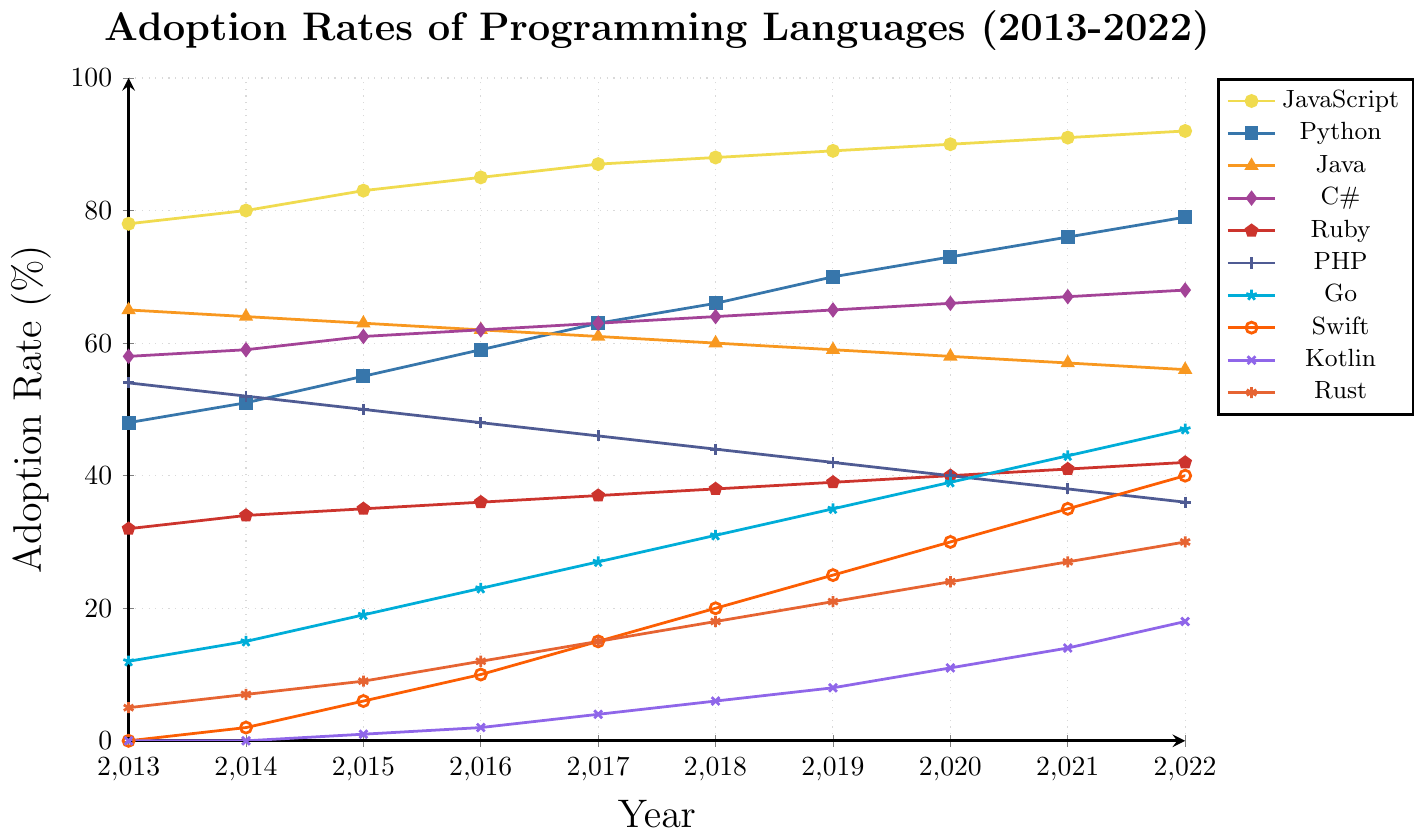Which programming language had the highest adoption rate in 2022? By referring to the legend and the data points for 2022, we can see that JavaScript has the highest adoption rate among all the programming languages listed.
Answer: JavaScript By how much did Python's adoption rate increase from 2013 to 2022? Find Python's adoption rate in 2013 (48%) and in 2022 (79%). The increase is 79 - 48 = 31%.
Answer: 31% Which programming language had the largest drop in adoption rate from 2013 to 2022? Check each language's adoption rate in 2013 and 2022. The language with the decrease is PHP, which dropped from 54% in 2013 to 36% in 2022.
Answer: PHP Between Go and Swift, which language saw a higher adoption rate in 2017? Compare the adoption rates of Go (27%) and Swift (15%) in 2017.
Answer: Go What is the average adoption rate of Java in the given decade? Sum the adoption rates of Java from 2013 to 2022 and divide by the number of years (10). (65 + 64 + 63 + 62 + 61 + 60 + 59 + 58 + 57 + 56) / 10 = 60.5%.
Answer: 60.5% Which language had a higher adoption rate in 2020, Kotlin or Rust? Compare the adoption rates of Kotlin (11%) and Rust (24%) in 2020.
Answer: Rust By how much did Swift’s adoption rate increase from 2013 to 2022? Find Swift's adoption rate in 2013 (0%) and in 2022 (40%). The increase is 40 - 0 = 40%.
Answer: 40% What is the difference in adoption rates between JavaScript and C# in 2019? Find JavaScript's (89%) and C#'s (65%) adoption rates in 2019. The difference is 89 - 65 = 24%.
Answer: 24% Which programming language showed a continuous increase in adoption rate every year from 2013 to 2022? Check each year's adoption rate for each language. Go is the language that shows a continuous increase every year.
Answer: Go What is the total increase in adoption rate for Rust from 2013 to 2022? Find Rust's adoption rate in 2013 (5%) and in 2022 (30%). The increase is 30 - 5 = 25%.
Answer: 25% 